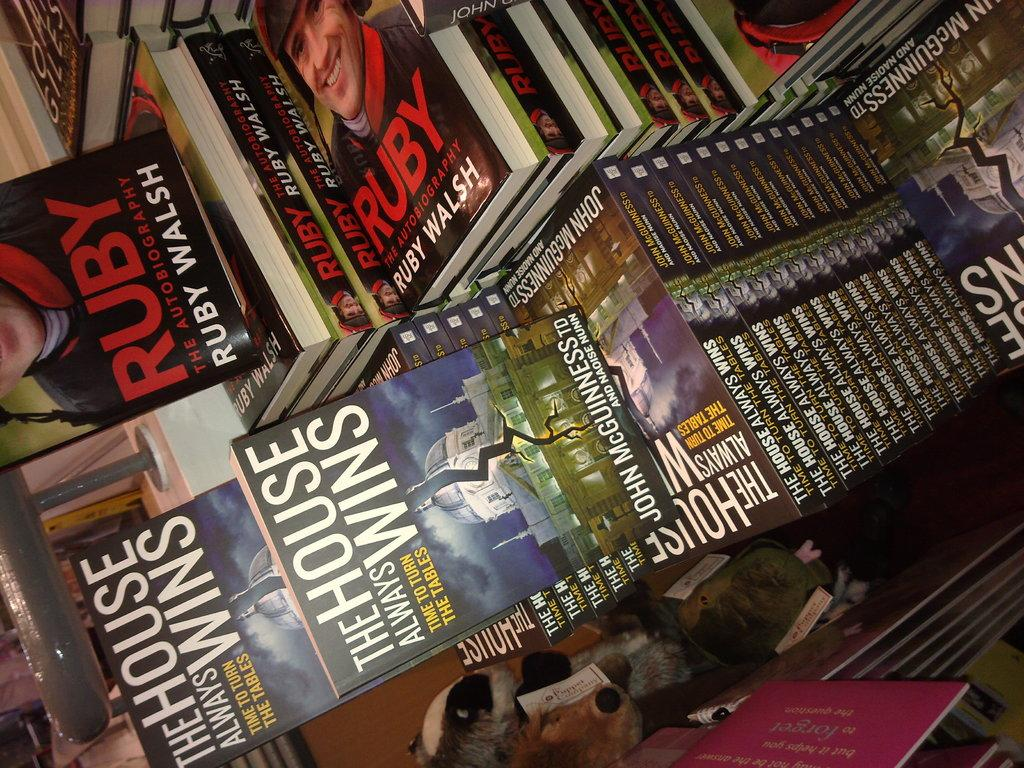<image>
Write a terse but informative summary of the picture. Books are piled up, including Ruday and The House Always Wins. 